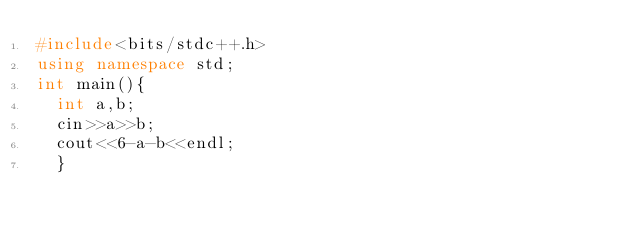<code> <loc_0><loc_0><loc_500><loc_500><_C++_>#include<bits/stdc++.h>
using namespace std;
int main(){
  int a,b;
  cin>>a>>b;
  cout<<6-a-b<<endl;
  }</code> 